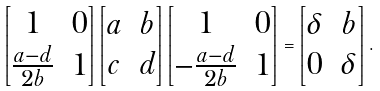<formula> <loc_0><loc_0><loc_500><loc_500>\begin{bmatrix} 1 & 0 \\ \frac { a - d } { 2 b } & 1 \end{bmatrix} \begin{bmatrix} a & b \\ c & d \end{bmatrix} \begin{bmatrix} 1 & 0 \\ - \frac { a - d } { 2 b } & 1 \end{bmatrix} = \begin{bmatrix} \delta & b \\ 0 & \delta \end{bmatrix} .</formula> 